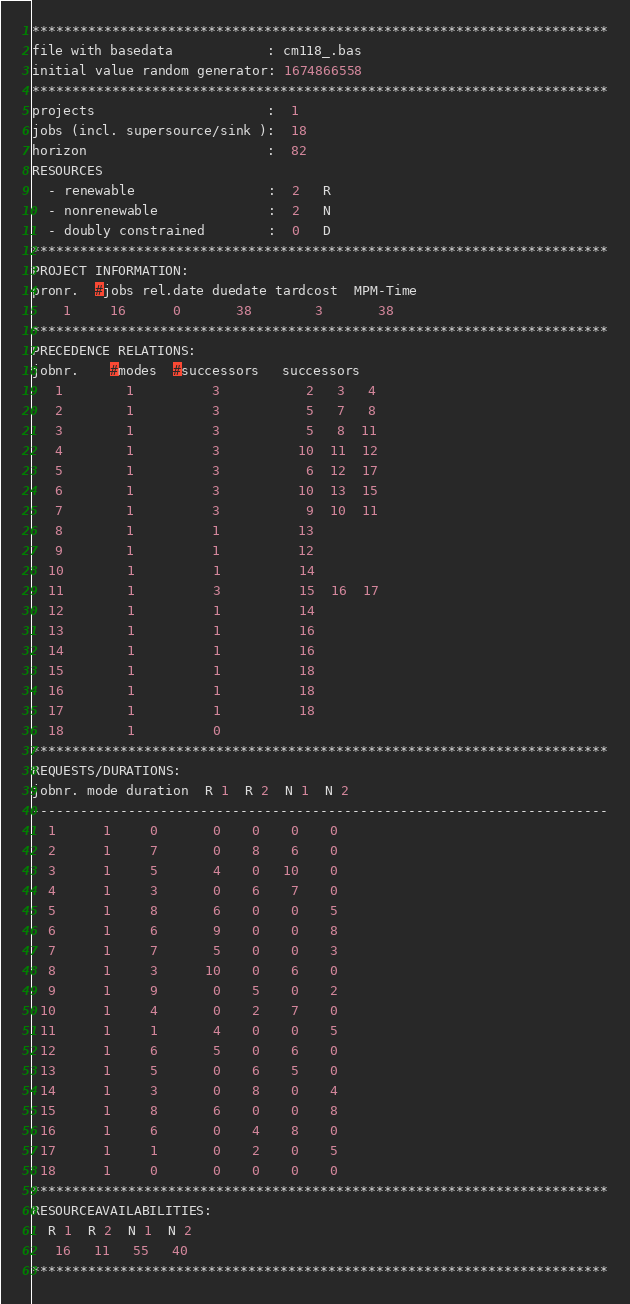Convert code to text. <code><loc_0><loc_0><loc_500><loc_500><_ObjectiveC_>************************************************************************
file with basedata            : cm118_.bas
initial value random generator: 1674866558
************************************************************************
projects                      :  1
jobs (incl. supersource/sink ):  18
horizon                       :  82
RESOURCES
  - renewable                 :  2   R
  - nonrenewable              :  2   N
  - doubly constrained        :  0   D
************************************************************************
PROJECT INFORMATION:
pronr.  #jobs rel.date duedate tardcost  MPM-Time
    1     16      0       38        3       38
************************************************************************
PRECEDENCE RELATIONS:
jobnr.    #modes  #successors   successors
   1        1          3           2   3   4
   2        1          3           5   7   8
   3        1          3           5   8  11
   4        1          3          10  11  12
   5        1          3           6  12  17
   6        1          3          10  13  15
   7        1          3           9  10  11
   8        1          1          13
   9        1          1          12
  10        1          1          14
  11        1          3          15  16  17
  12        1          1          14
  13        1          1          16
  14        1          1          16
  15        1          1          18
  16        1          1          18
  17        1          1          18
  18        1          0        
************************************************************************
REQUESTS/DURATIONS:
jobnr. mode duration  R 1  R 2  N 1  N 2
------------------------------------------------------------------------
  1      1     0       0    0    0    0
  2      1     7       0    8    6    0
  3      1     5       4    0   10    0
  4      1     3       0    6    7    0
  5      1     8       6    0    0    5
  6      1     6       9    0    0    8
  7      1     7       5    0    0    3
  8      1     3      10    0    6    0
  9      1     9       0    5    0    2
 10      1     4       0    2    7    0
 11      1     1       4    0    0    5
 12      1     6       5    0    6    0
 13      1     5       0    6    5    0
 14      1     3       0    8    0    4
 15      1     8       6    0    0    8
 16      1     6       0    4    8    0
 17      1     1       0    2    0    5
 18      1     0       0    0    0    0
************************************************************************
RESOURCEAVAILABILITIES:
  R 1  R 2  N 1  N 2
   16   11   55   40
************************************************************************
</code> 